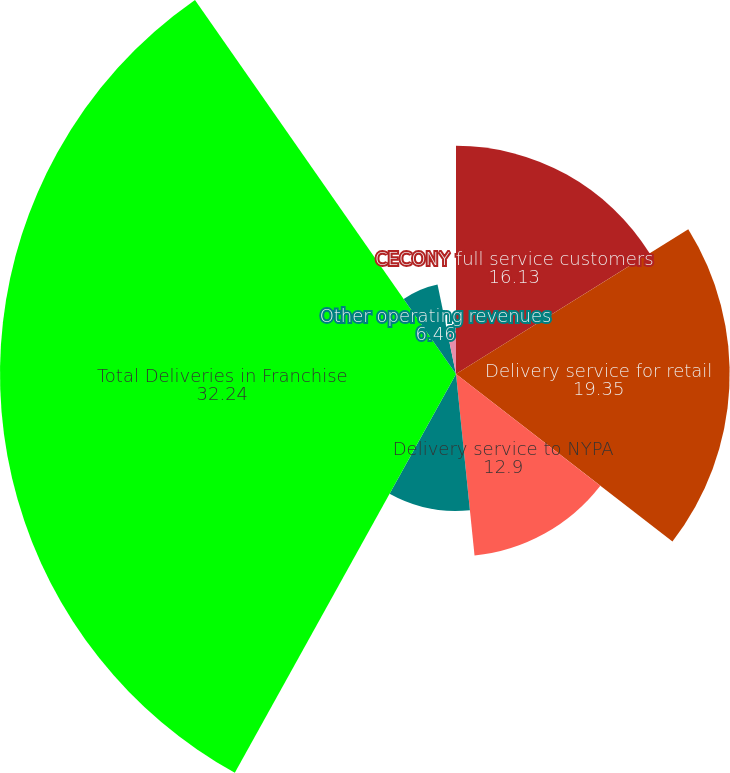Convert chart to OTSL. <chart><loc_0><loc_0><loc_500><loc_500><pie_chart><fcel>CECONY full service customers<fcel>Delivery service for retail<fcel>Delivery service to NYPA<fcel>Delivery service for municipal<fcel>Total Deliveries in Franchise<fcel>Other operating revenues<fcel>Residential<fcel>Commercial and Industrial<nl><fcel>16.13%<fcel>19.35%<fcel>12.9%<fcel>9.68%<fcel>32.24%<fcel>6.46%<fcel>3.23%<fcel>0.01%<nl></chart> 